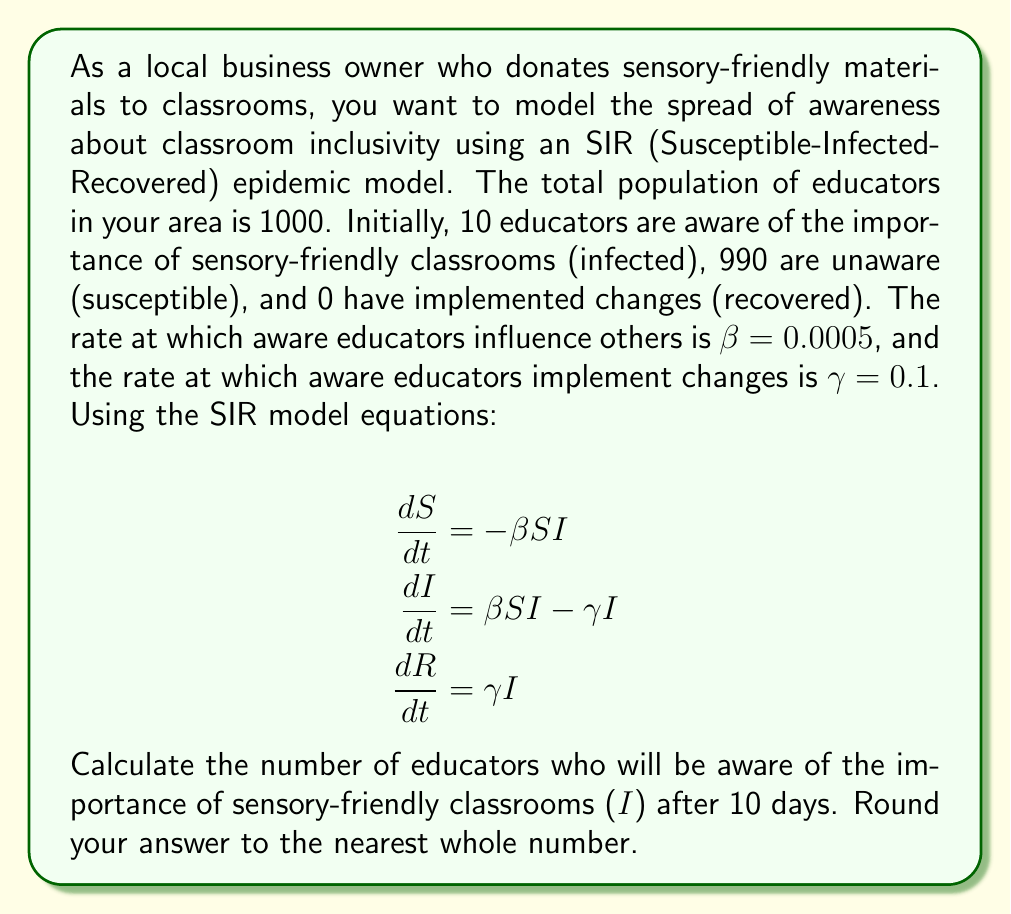Provide a solution to this math problem. To solve this problem, we'll use the SIR model equations and numerical integration. We'll use the Euler method for simplicity.

Given:
- Total population N = 1000
- Initial conditions: S(0) = 990, I(0) = 10, R(0) = 0
- β = 0.0005, γ = 0.1
- Time step Δt = 1 day, total time T = 10 days

Step 1: Set up the Euler method equations
For each time step:
$$S_{t+1} = S_t + (-βS_tI_t)Δt$$
$$I_{t+1} = I_t + (βS_tI_t - γI_t)Δt$$
$$R_{t+1} = R_t + (γI_t)Δt$$

Step 2: Create a table to calculate values for each day
| Day | S | I | R |
|-----|---|---|---|
| 0 | 990 | 10 | 0 |
| 1 | 985.05 | 14.45 | 0.5 |
| 2 | 978.03 | 20.87 | 1.10 |
| 3 | 968.05 | 29.75 | 2.20 |
| 4 | 953.90 | 41.55 | 4.55 |
| 5 | 934.18 | 57.17 | 8.65 |
| 6 | 907.17 | 77.18 | 15.65 |
| 7 | 871.01 | 102.09 | 26.90 |
| 8 | 824.01 | 131.99 | 44.00 |
| 9 | 765.07 | 166.93 | 68.00 |
| 10 | 693.55 | 206.52 | 99.93 |

Step 3: Round the final I value to the nearest whole number
I(10) ≈ 207
Answer: 207 educators 